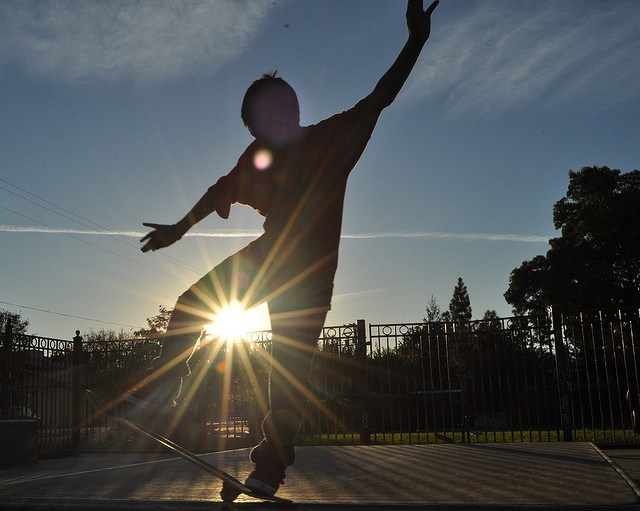Describe the objects in this image and their specific colors. I can see people in gray and black tones and skateboard in gray and black tones in this image. 